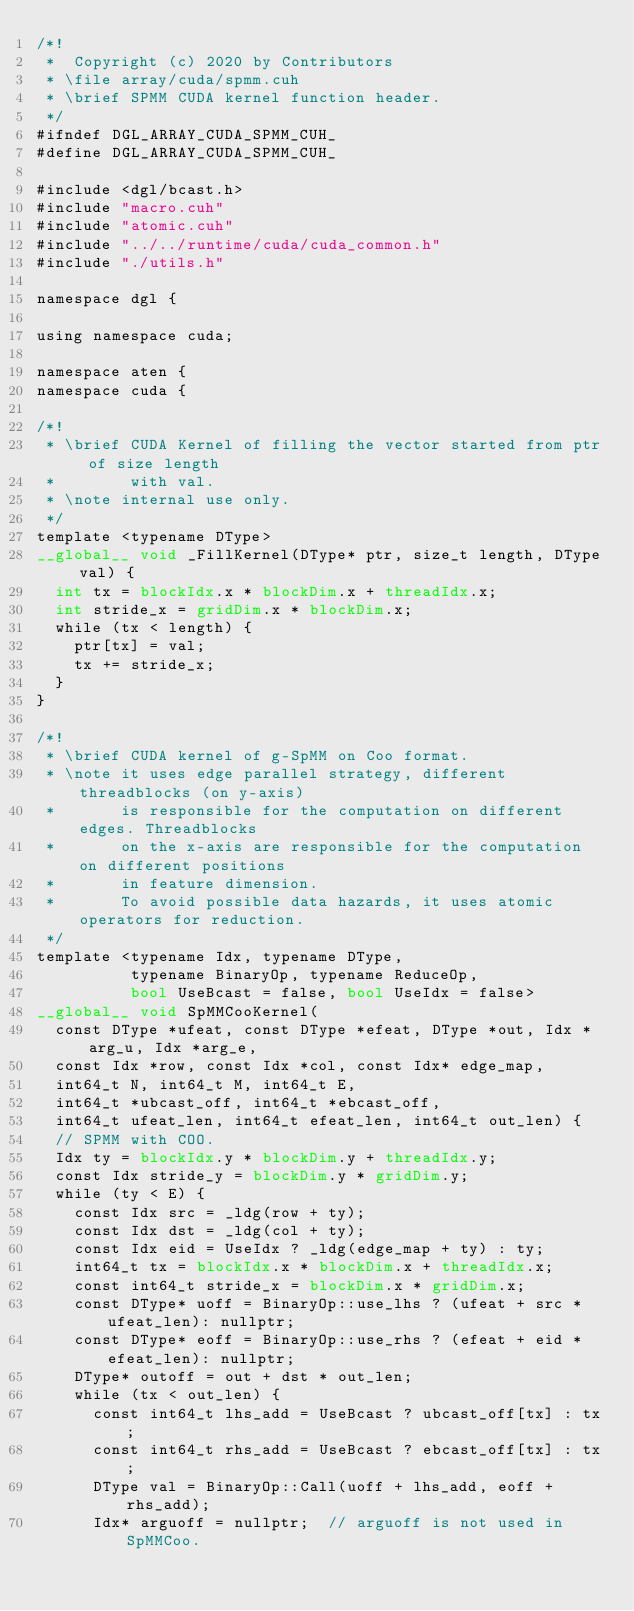<code> <loc_0><loc_0><loc_500><loc_500><_Cuda_>/*!
 *  Copyright (c) 2020 by Contributors
 * \file array/cuda/spmm.cuh
 * \brief SPMM CUDA kernel function header.
 */
#ifndef DGL_ARRAY_CUDA_SPMM_CUH_
#define DGL_ARRAY_CUDA_SPMM_CUH_

#include <dgl/bcast.h>
#include "macro.cuh"
#include "atomic.cuh"
#include "../../runtime/cuda/cuda_common.h"
#include "./utils.h"

namespace dgl {

using namespace cuda;

namespace aten {
namespace cuda {

/*! 
 * \brief CUDA Kernel of filling the vector started from ptr of size length
 *        with val.
 * \note internal use only.
 */
template <typename DType>
__global__ void _FillKernel(DType* ptr, size_t length, DType val) {
  int tx = blockIdx.x * blockDim.x + threadIdx.x;
  int stride_x = gridDim.x * blockDim.x;
  while (tx < length) {
    ptr[tx] = val;
    tx += stride_x;
  }
}

/*!
 * \brief CUDA kernel of g-SpMM on Coo format.
 * \note it uses edge parallel strategy, different threadblocks (on y-axis)
 *       is responsible for the computation on different edges. Threadblocks
 *       on the x-axis are responsible for the computation on different positions
 *       in feature dimension.
 *       To avoid possible data hazards, it uses atomic operators for reduction.
 */
template <typename Idx, typename DType,
          typename BinaryOp, typename ReduceOp,
          bool UseBcast = false, bool UseIdx = false>
__global__ void SpMMCooKernel(
  const DType *ufeat, const DType *efeat, DType *out, Idx *arg_u, Idx *arg_e,
  const Idx *row, const Idx *col, const Idx* edge_map,
  int64_t N, int64_t M, int64_t E,
  int64_t *ubcast_off, int64_t *ebcast_off,
  int64_t ufeat_len, int64_t efeat_len, int64_t out_len) {
  // SPMM with COO.
  Idx ty = blockIdx.y * blockDim.y + threadIdx.y;
  const Idx stride_y = blockDim.y * gridDim.y;
  while (ty < E) {
    const Idx src = _ldg(row + ty);
    const Idx dst = _ldg(col + ty);
    const Idx eid = UseIdx ? _ldg(edge_map + ty) : ty;
    int64_t tx = blockIdx.x * blockDim.x + threadIdx.x;
    const int64_t stride_x = blockDim.x * gridDim.x;
    const DType* uoff = BinaryOp::use_lhs ? (ufeat + src * ufeat_len): nullptr;
    const DType* eoff = BinaryOp::use_rhs ? (efeat + eid * efeat_len): nullptr;
    DType* outoff = out + dst * out_len;
    while (tx < out_len) {
      const int64_t lhs_add = UseBcast ? ubcast_off[tx] : tx;
      const int64_t rhs_add = UseBcast ? ebcast_off[tx] : tx;
      DType val = BinaryOp::Call(uoff + lhs_add, eoff + rhs_add);
      Idx* arguoff = nullptr;  // arguoff is not used in SpMMCoo.</code> 